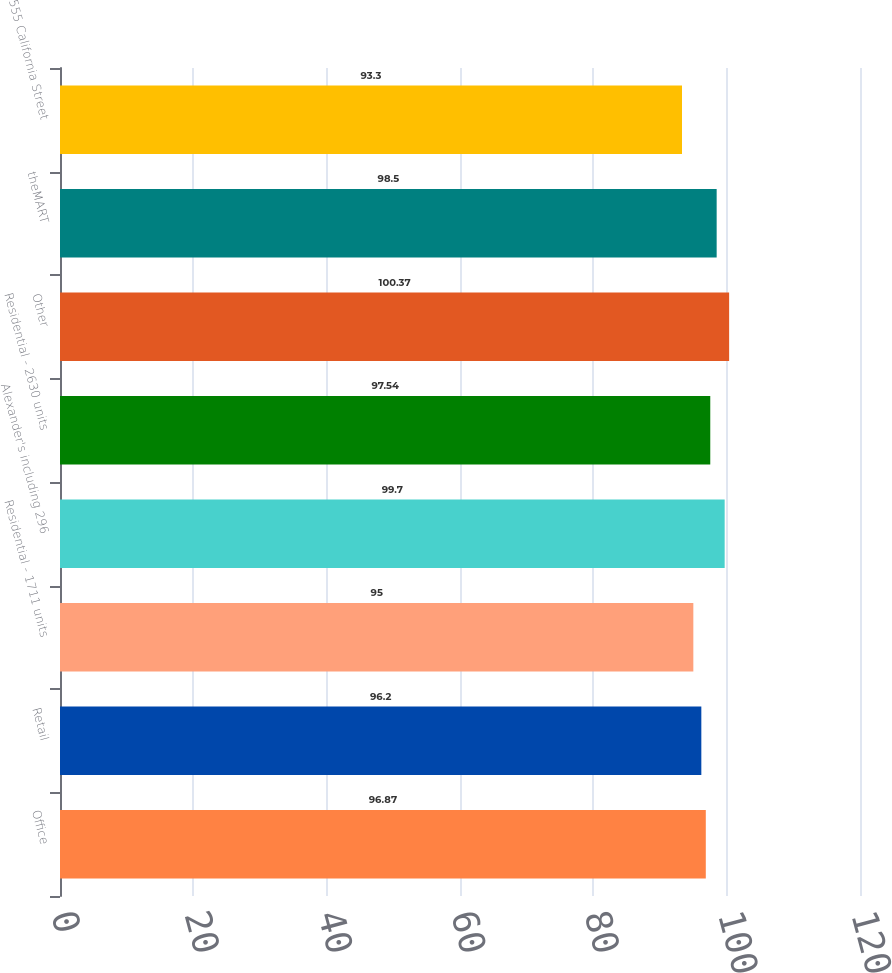Convert chart. <chart><loc_0><loc_0><loc_500><loc_500><bar_chart><fcel>Office<fcel>Retail<fcel>Residential - 1711 units<fcel>Alexander's including 296<fcel>Residential - 2630 units<fcel>Other<fcel>theMART<fcel>555 California Street<nl><fcel>96.87<fcel>96.2<fcel>95<fcel>99.7<fcel>97.54<fcel>100.37<fcel>98.5<fcel>93.3<nl></chart> 